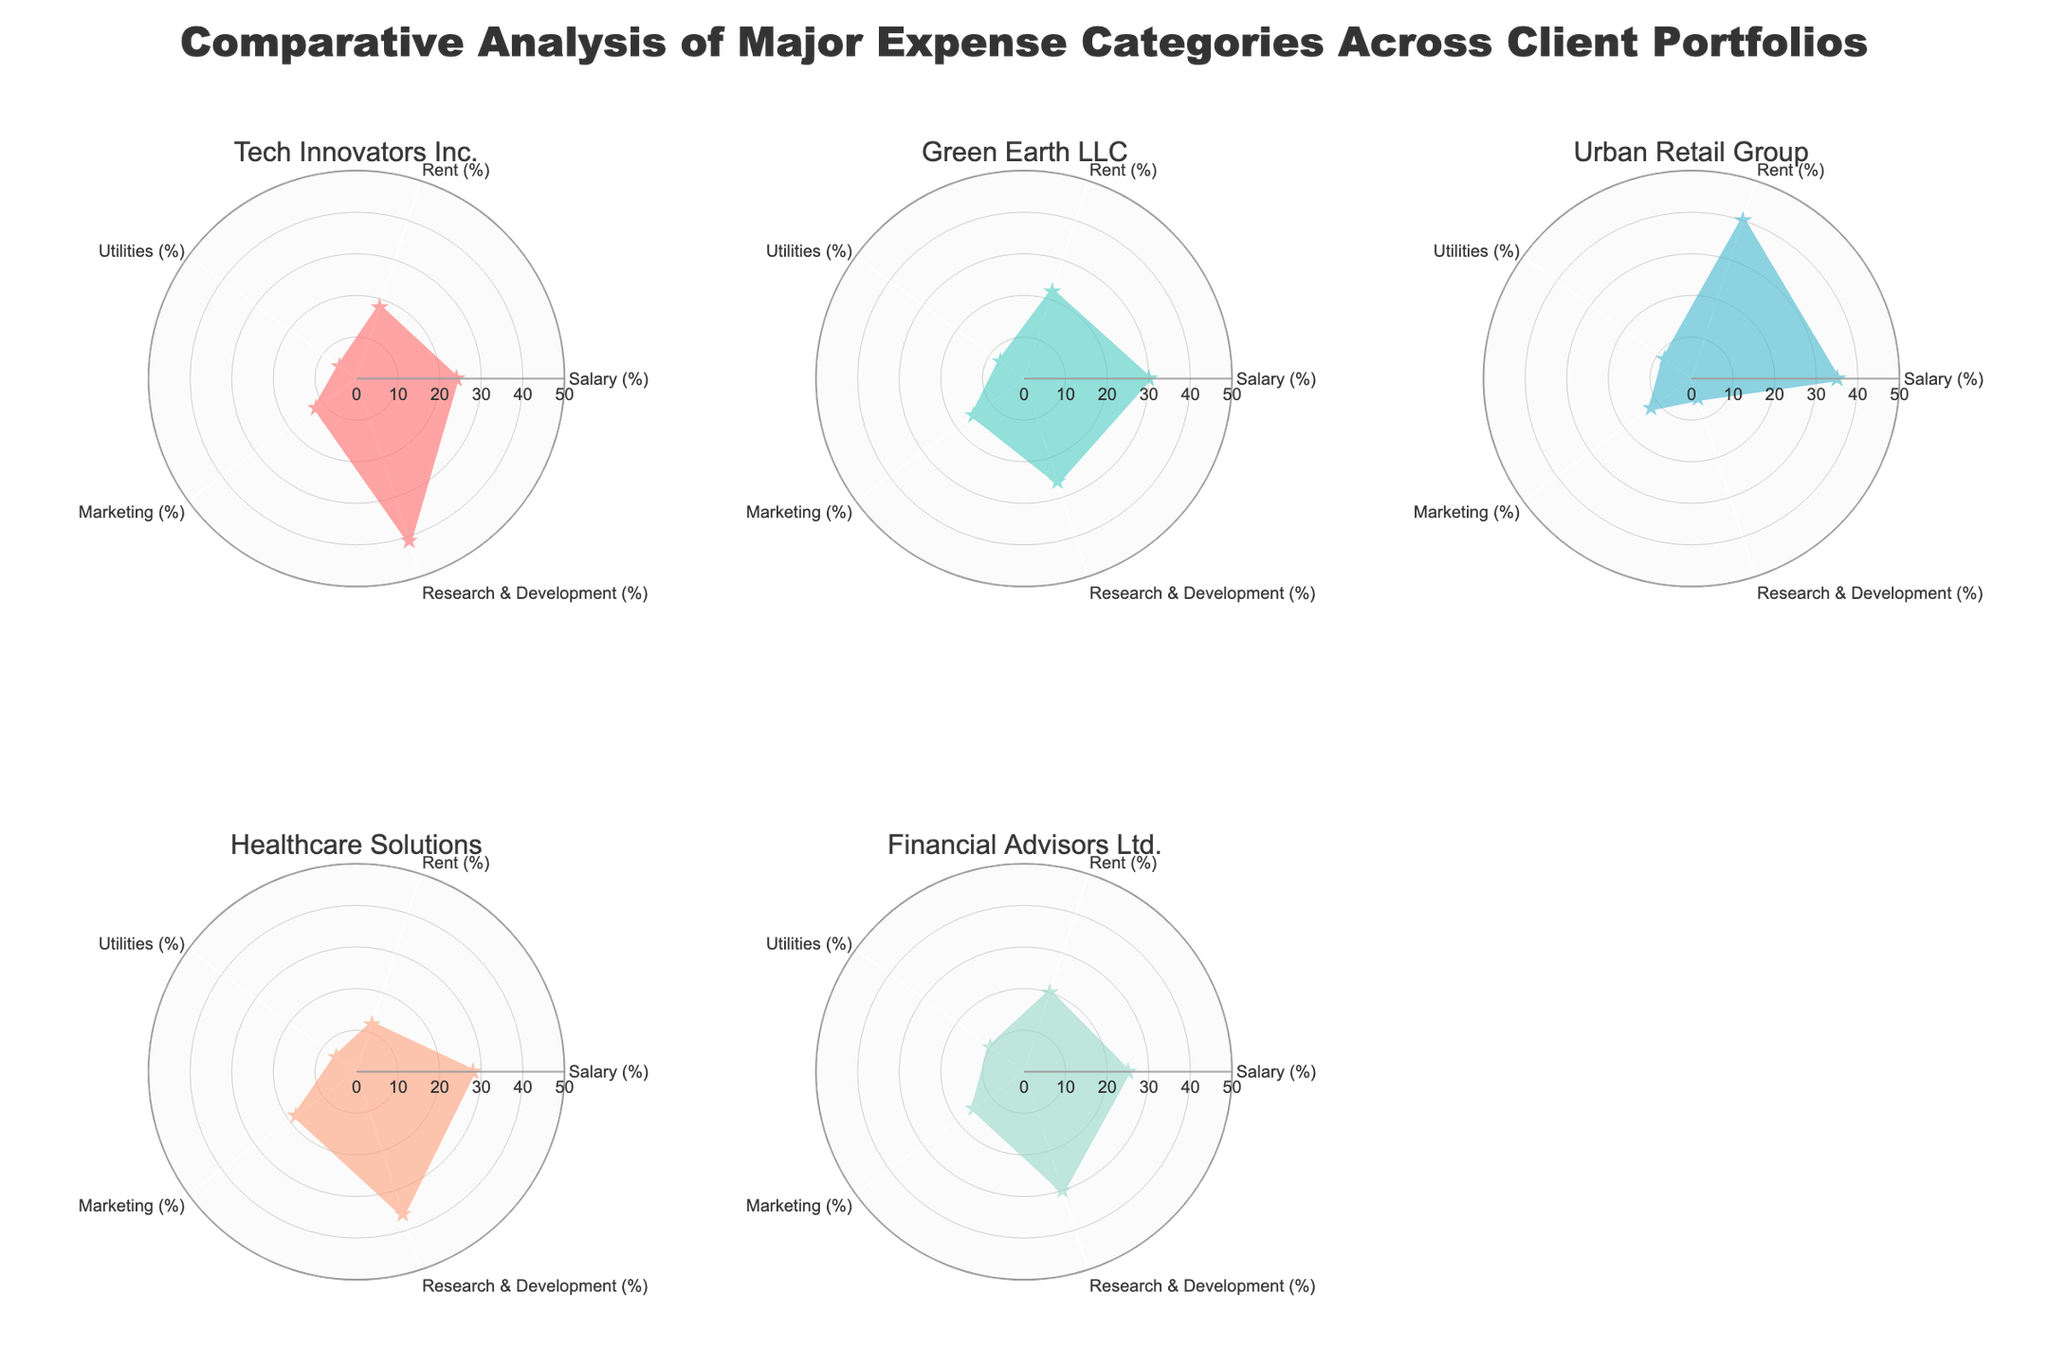What is the highest percentage allocated to salaries among the clients? Tech Innovators Inc. allocates 24%, Green Earth LLC allocates 30%, Urban Retail Group allocates 35%, Healthcare Solutions allocates 28%, and Financial Advisors Ltd. allocates 25%. Therefore, Urban Retail Group has the highest percentage.
Answer: 35% Which client allocates the most to Research & Development? Tech Innovators Inc. allocates 41%, Green Earth LLC allocates 26%, Urban Retail Group allocates 5%, Healthcare Solutions allocates 36%, and Financial Advisors Ltd. allocates 30%. Therefore, Tech Innovators Inc. allocates the most.
Answer: Tech Innovators Inc What is the total percentage of Rent expenses for Green Earth LLC and Urban Retail Group combined? Green Earth LLC allocates 22% and Urban Retail Group allocates 40%. Summing them gives 22% + 40% = 62%.
Answer: 62% Which two clients allocate the same percentage to Marketing? The given clients and their Marketing allocations are: Tech Innovators Inc. (12%), Green Earth LLC (15%), Urban Retail Group (12%), Healthcare Solutions (18%), and Financial Advisors Ltd. (15%). Tech Innovators Inc. and Urban Retail Group both allocate 12%.
Answer: Tech Innovators Inc. and Urban Retail Group What category forms the smallest percentage for Healthcare Solutions? The percentages for Healthcare Solutions are: Salary (28%), Rent (12%), Utilities (6%), Marketing (18%), and Research & Development (36%). Therefore, Utilities is the smallest category.
Answer: Utilities By how much does the percentage of Research & Development in Financial Advisors Ltd. exceed that of Urban Retail Group? Urban Retail Group allocates 5% and Financial Advisors Ltd. allocates 30%. The difference is 30% - 5% = 25%.
Answer: 25% What is the average percentage allocation to Utilities across all clients? The percentages of Utilities are: Tech Innovators Inc. (5%), Green Earth LLC (7%), Urban Retail Group (8%), Healthcare Solutions (6%), and Financial Advisors Ltd. (10%). The sum is 5% + 7% + 8% + 6% + 10% = 36%. The average is 36% / 5 = 7.2%.
Answer: 7.2% 